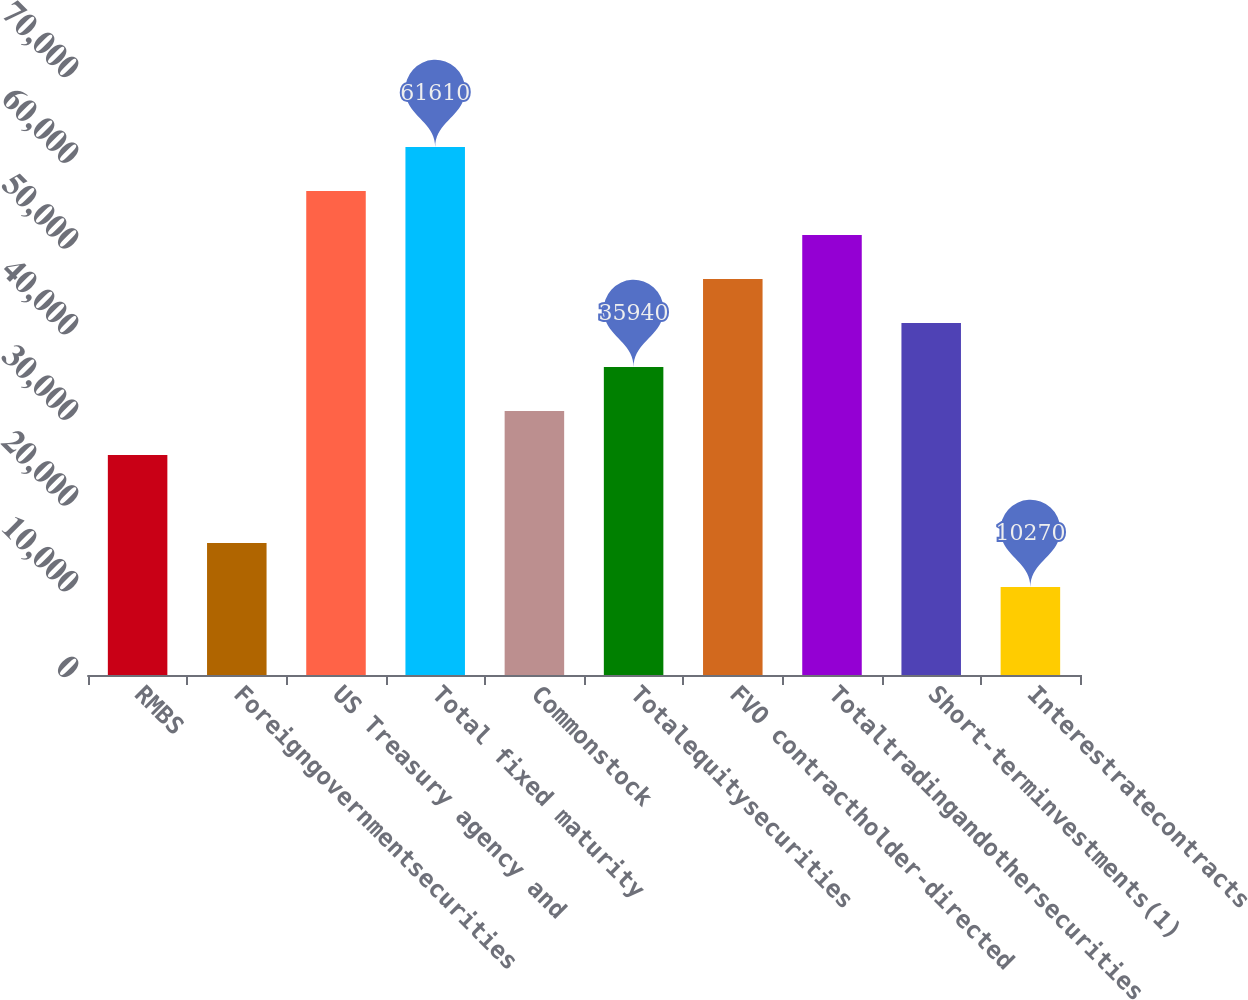Convert chart. <chart><loc_0><loc_0><loc_500><loc_500><bar_chart><fcel>RMBS<fcel>Foreigngovernmentsecurities<fcel>US Treasury agency and<fcel>Total fixed maturity<fcel>Commonstock<fcel>Totalequitysecurities<fcel>FVO contractholder-directed<fcel>Totaltradingandothersecurities<fcel>Short-terminvestments(1)<fcel>Interestratecontracts<nl><fcel>25672<fcel>15404<fcel>56476<fcel>61610<fcel>30806<fcel>35940<fcel>46208<fcel>51342<fcel>41074<fcel>10270<nl></chart> 